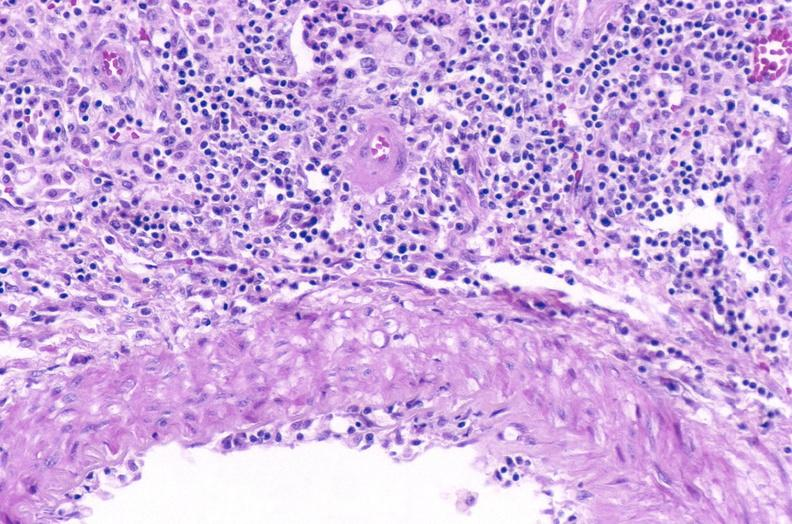where is this?
Answer the question using a single word or phrase. Urinary 